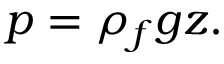<formula> <loc_0><loc_0><loc_500><loc_500>p = \rho _ { f } g z .</formula> 